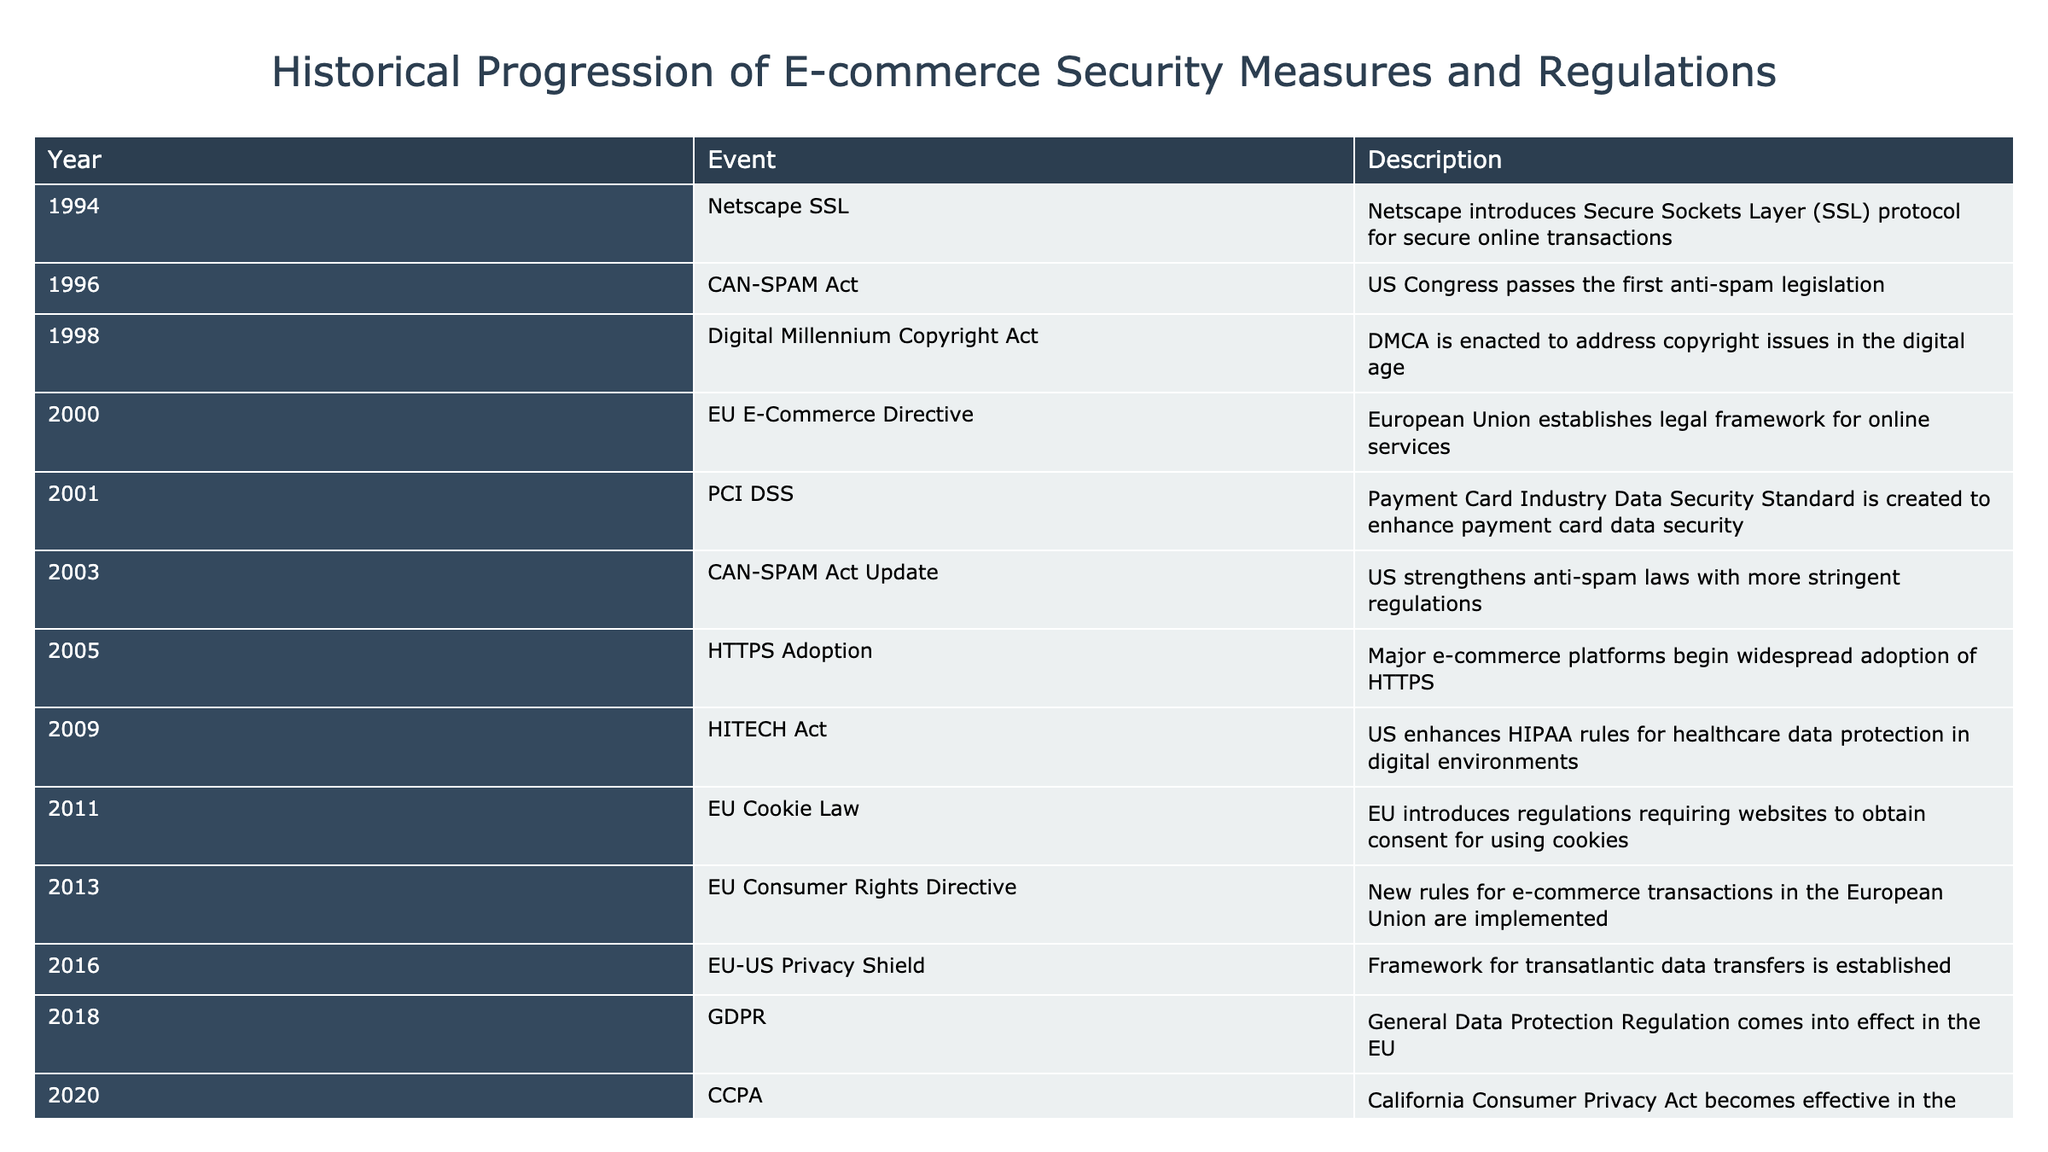What year was the GDPR enacted? The table shows that the General Data Protection Regulation (GDPR) came into effect in the year 2018.
Answer: 2018 Which act was aimed at addressing spam in the US? The table lists the CAN-SPAM Act, which was first passed in 2003 and updated in 2005, as the legislation aimed at tackling spam in the United States.
Answer: CAN-SPAM Act How many security measures and regulations were introduced between 2000 and 2010? By reviewing the years from 2000 to 2010 in the table, the following events are identified: EU E-Commerce Directive (2000), PCI DSS (2001), HITECH Act (2009). This gives us a total of three regulations.
Answer: 3 Did the EU introduce any regulations before 2010 regarding online privacy? The table indicates that the EU Cookie Law was introduced in 2011, which shows there were no EU regulations specifically regarding online privacy before 2010.
Answer: No What is the difference in years between the introduction of PCI DSS and GDPR? The PCI DSS was introduced in 2001 and the GDPR was enacted in 2018. The difference between these years is 2018 - 2001 = 17 years.
Answer: 17 years How many measures focused on data security were introduced after 2013? The measures introduced after 2013 are Strong Customer Authentication in 2021 and the Digital Markets Act in 2023. This totals two measures focused on data security introduced after 2013.
Answer: 2 Was HTTPS adoption widespread among major e-commerce platforms before 2010? According to the table, widespread adoption of HTTPS by major e-commerce platforms began in 2005, which confirms that it was adopted before the year 2010.
Answer: Yes What percentage of events in the table relates to privacy regulations? There are 6 events in the table that can be categorized as privacy regulations: CAN-SPAM Act (1996, 2003), Digital Millennium Copyright Act (1998), EU Cookie Law (2011), GDPR (2018), and CCPA (2020), totaling 6 out of 20 events. Therefore, the percentage is (6/20) * 100 = 30%.
Answer: 30% What was the most recent e-commerce regulation mentioned? The table indicates that the most recent e-commerce regulation is the Digital Markets Act introduced in 2023, which is the last event listed in the table.
Answer: Digital Markets Act 